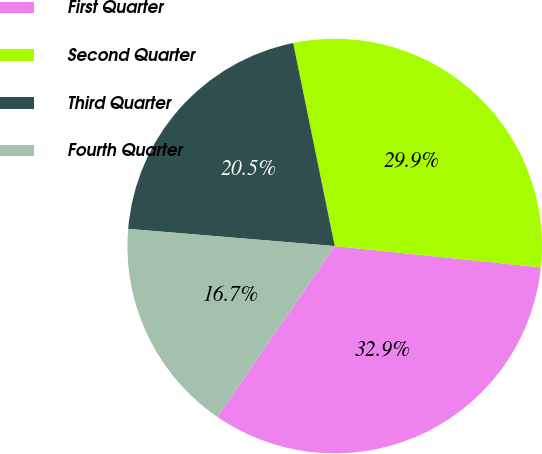Convert chart. <chart><loc_0><loc_0><loc_500><loc_500><pie_chart><fcel>First Quarter<fcel>Second Quarter<fcel>Third Quarter<fcel>Fourth Quarter<nl><fcel>32.94%<fcel>29.85%<fcel>20.46%<fcel>16.74%<nl></chart> 